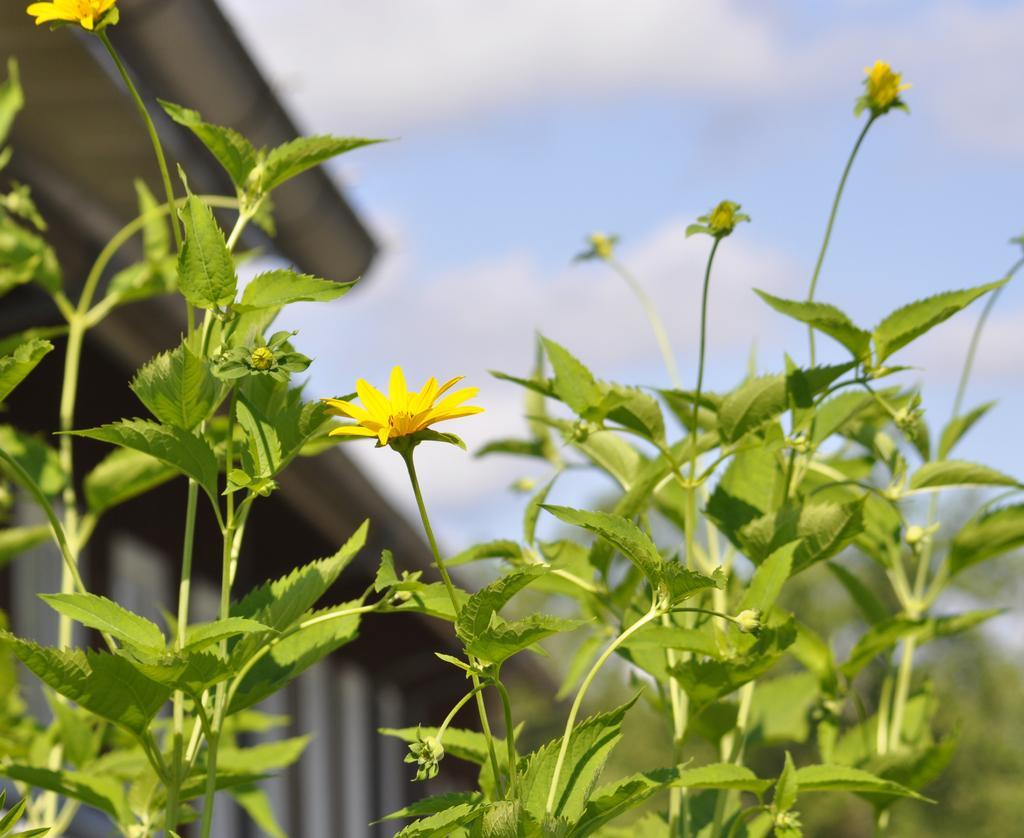Can you describe this image briefly? In this image, we can see some plants and there are some flowers, at the top we can see the sky. 